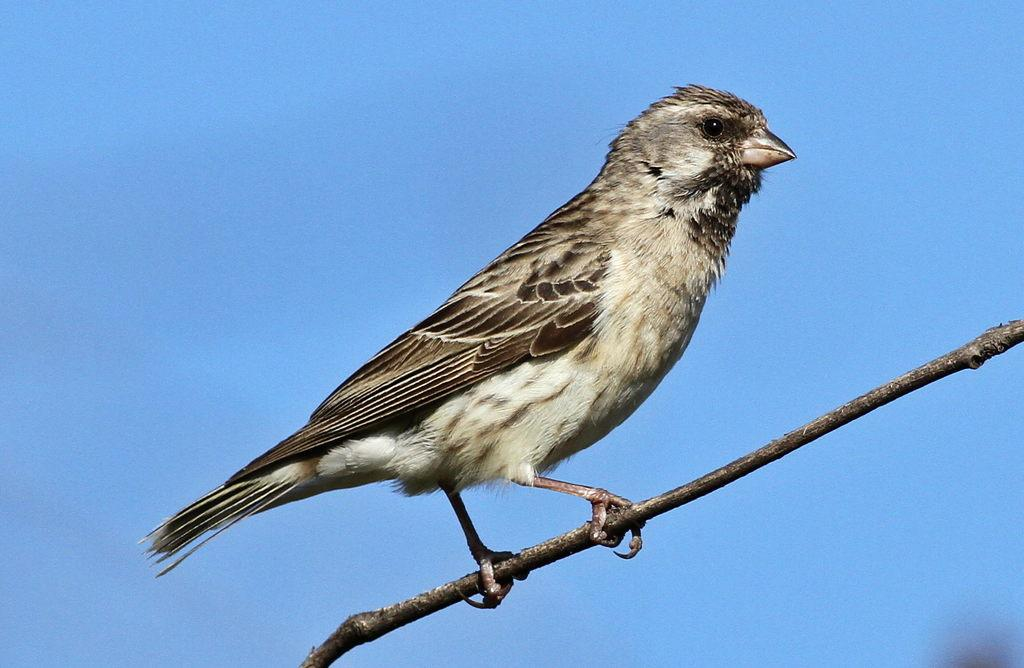What type of animal can be seen in the image? There is a bird in the image. Where is the bird located? The bird is standing on a branch. What can be seen behind the bird? The sky is visible behind the bird. How many nails are holding the bird to the branch in the image? There are no nails present in the image, and the bird is not attached to the branch. What type of potato is visible in the image? There are no potatoes present in the image. 